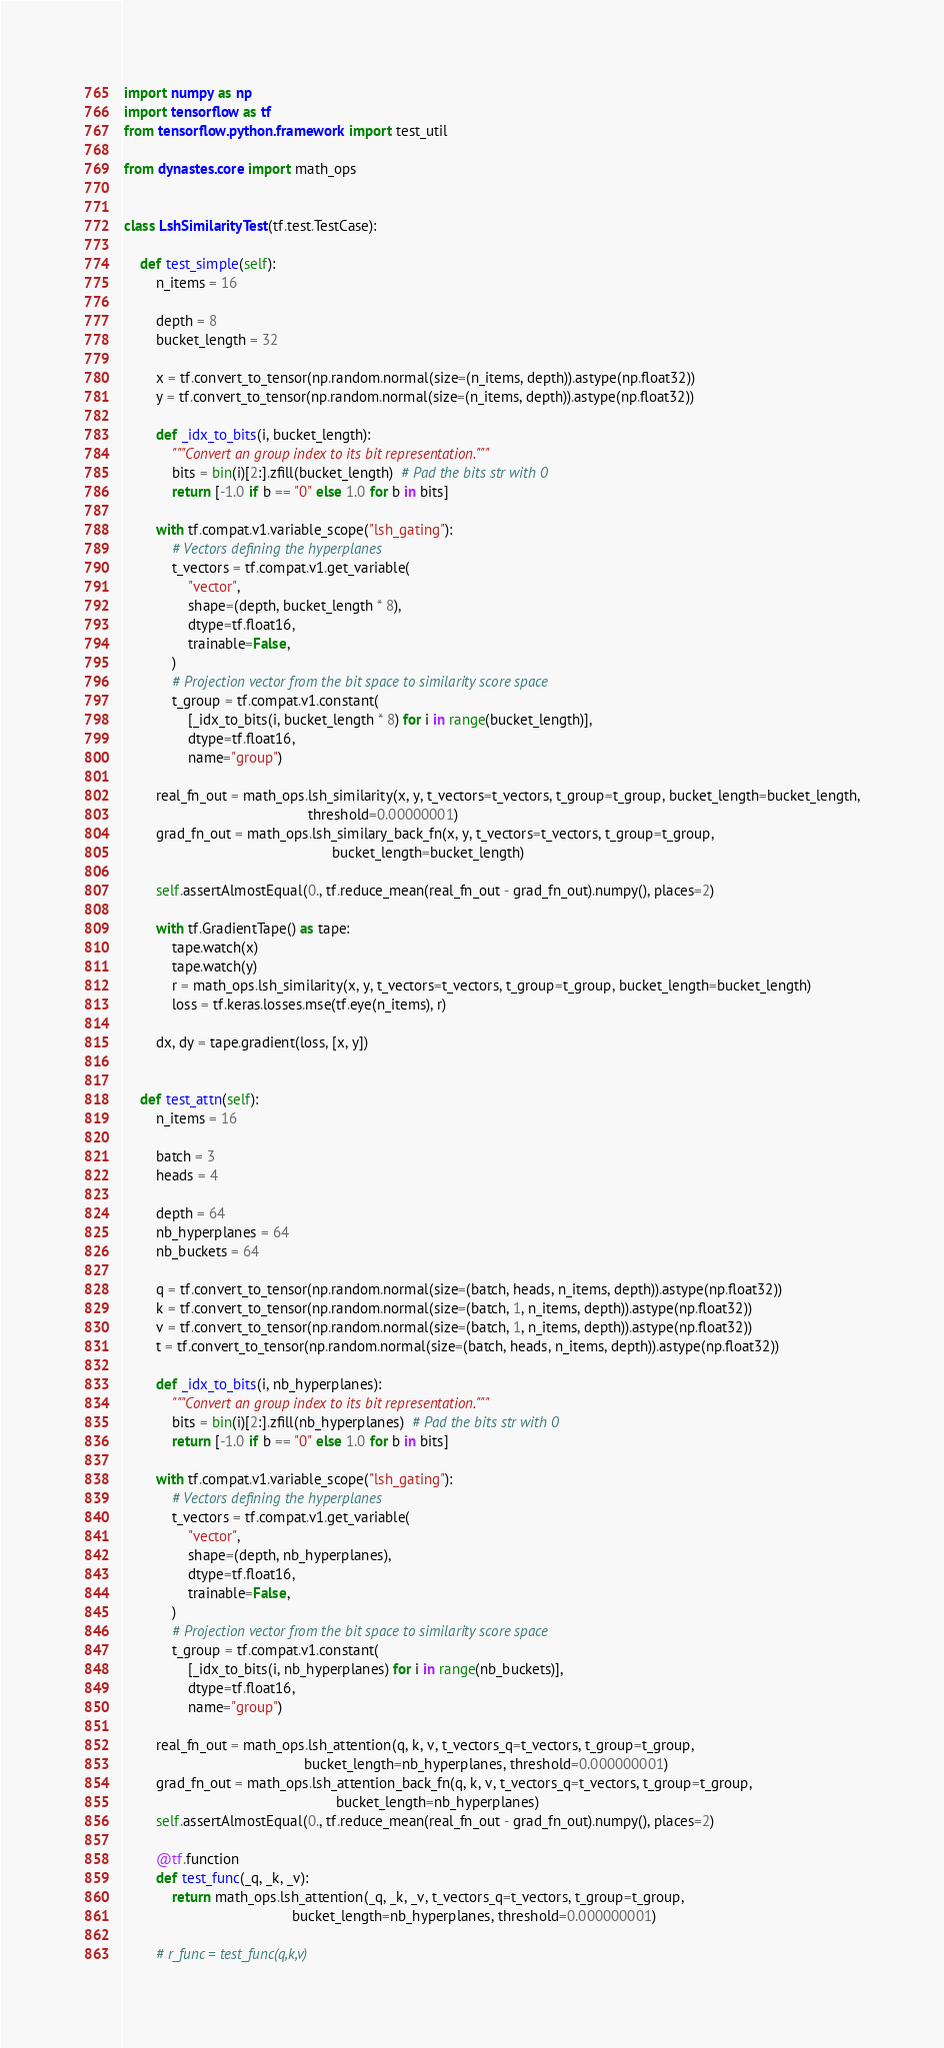Convert code to text. <code><loc_0><loc_0><loc_500><loc_500><_Python_>import numpy as np
import tensorflow as tf
from tensorflow.python.framework import test_util

from dynastes.core import math_ops


class LshSimilarityTest(tf.test.TestCase):

    def test_simple(self):
        n_items = 16

        depth = 8
        bucket_length = 32

        x = tf.convert_to_tensor(np.random.normal(size=(n_items, depth)).astype(np.float32))
        y = tf.convert_to_tensor(np.random.normal(size=(n_items, depth)).astype(np.float32))

        def _idx_to_bits(i, bucket_length):
            """Convert an group index to its bit representation."""
            bits = bin(i)[2:].zfill(bucket_length)  # Pad the bits str with 0
            return [-1.0 if b == "0" else 1.0 for b in bits]

        with tf.compat.v1.variable_scope("lsh_gating"):
            # Vectors defining the hyperplanes
            t_vectors = tf.compat.v1.get_variable(
                "vector",
                shape=(depth, bucket_length * 8),
                dtype=tf.float16,
                trainable=False,
            )
            # Projection vector from the bit space to similarity score space
            t_group = tf.compat.v1.constant(
                [_idx_to_bits(i, bucket_length * 8) for i in range(bucket_length)],
                dtype=tf.float16,
                name="group")

        real_fn_out = math_ops.lsh_similarity(x, y, t_vectors=t_vectors, t_group=t_group, bucket_length=bucket_length,
                                              threshold=0.00000001)
        grad_fn_out = math_ops.lsh_similary_back_fn(x, y, t_vectors=t_vectors, t_group=t_group,
                                                    bucket_length=bucket_length)

        self.assertAlmostEqual(0., tf.reduce_mean(real_fn_out - grad_fn_out).numpy(), places=2)

        with tf.GradientTape() as tape:
            tape.watch(x)
            tape.watch(y)
            r = math_ops.lsh_similarity(x, y, t_vectors=t_vectors, t_group=t_group, bucket_length=bucket_length)
            loss = tf.keras.losses.mse(tf.eye(n_items), r)

        dx, dy = tape.gradient(loss, [x, y])


    def test_attn(self):
        n_items = 16

        batch = 3
        heads = 4

        depth = 64
        nb_hyperplanes = 64
        nb_buckets = 64

        q = tf.convert_to_tensor(np.random.normal(size=(batch, heads, n_items, depth)).astype(np.float32))
        k = tf.convert_to_tensor(np.random.normal(size=(batch, 1, n_items, depth)).astype(np.float32))
        v = tf.convert_to_tensor(np.random.normal(size=(batch, 1, n_items, depth)).astype(np.float32))
        t = tf.convert_to_tensor(np.random.normal(size=(batch, heads, n_items, depth)).astype(np.float32))

        def _idx_to_bits(i, nb_hyperplanes):
            """Convert an group index to its bit representation."""
            bits = bin(i)[2:].zfill(nb_hyperplanes)  # Pad the bits str with 0
            return [-1.0 if b == "0" else 1.0 for b in bits]

        with tf.compat.v1.variable_scope("lsh_gating"):
            # Vectors defining the hyperplanes
            t_vectors = tf.compat.v1.get_variable(
                "vector",
                shape=(depth, nb_hyperplanes),
                dtype=tf.float16,
                trainable=False,
            )
            # Projection vector from the bit space to similarity score space
            t_group = tf.compat.v1.constant(
                [_idx_to_bits(i, nb_hyperplanes) for i in range(nb_buckets)],
                dtype=tf.float16,
                name="group")

        real_fn_out = math_ops.lsh_attention(q, k, v, t_vectors_q=t_vectors, t_group=t_group,
                                             bucket_length=nb_hyperplanes, threshold=0.000000001)
        grad_fn_out = math_ops.lsh_attention_back_fn(q, k, v, t_vectors_q=t_vectors, t_group=t_group,
                                                     bucket_length=nb_hyperplanes)
        self.assertAlmostEqual(0., tf.reduce_mean(real_fn_out - grad_fn_out).numpy(), places=2)

        @tf.function
        def test_func(_q, _k, _v):
            return math_ops.lsh_attention(_q, _k, _v, t_vectors_q=t_vectors, t_group=t_group,
                                          bucket_length=nb_hyperplanes, threshold=0.000000001)

        # r_func = test_func(q,k,v)
</code> 